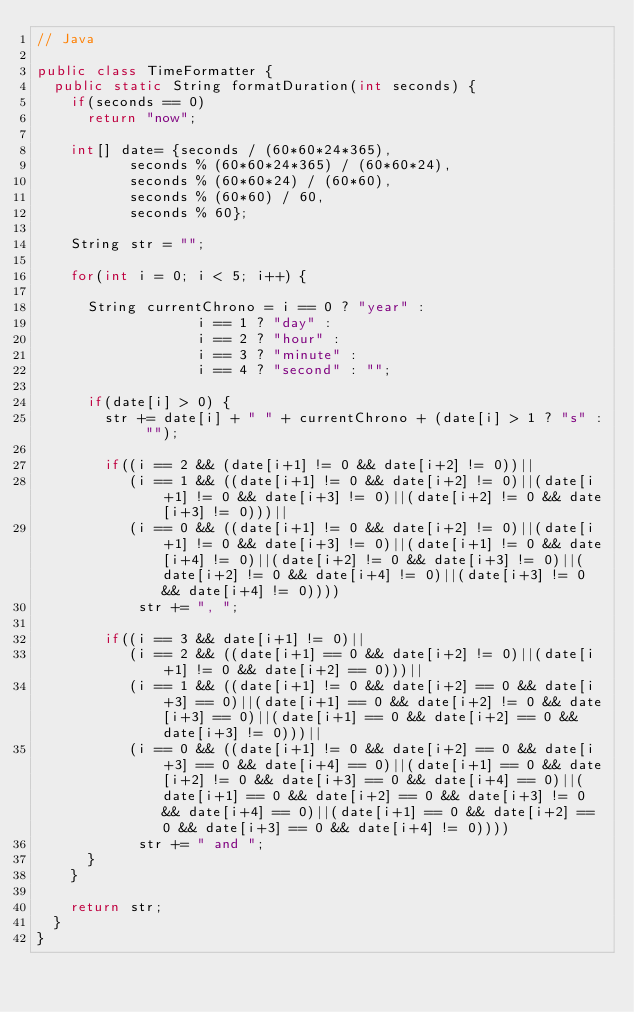Convert code to text. <code><loc_0><loc_0><loc_500><loc_500><_Java_>// Java

public class TimeFormatter {
  public static String formatDuration(int seconds) {
    if(seconds == 0)
      return "now";
    
    int[] date= {seconds / (60*60*24*365),
           seconds % (60*60*24*365) / (60*60*24),
           seconds % (60*60*24) / (60*60),
           seconds % (60*60) / 60,
           seconds % 60};
    
    String str = "";
    
    for(int i = 0; i < 5; i++) {
      
      String currentChrono = i == 0 ? "year" :
                   i == 1 ? "day" :
                   i == 2 ? "hour" : 
                   i == 3 ? "minute" : 
                   i == 4 ? "second" : "";
      
      if(date[i] > 0) {
        str += date[i] + " " + currentChrono + (date[i] > 1 ? "s" : "");
        
        if((i == 2 && (date[i+1] != 0 && date[i+2] != 0))||
           (i == 1 && ((date[i+1] != 0 && date[i+2] != 0)||(date[i+1] != 0 && date[i+3] != 0)||(date[i+2] != 0 && date[i+3] != 0)))||
           (i == 0 && ((date[i+1] != 0 && date[i+2] != 0)||(date[i+1] != 0 && date[i+3] != 0)||(date[i+1] != 0 && date[i+4] != 0)||(date[i+2] != 0 && date[i+3] != 0)||(date[i+2] != 0 && date[i+4] != 0)||(date[i+3] != 0 && date[i+4] != 0))))
            str += ", ";

        if((i == 3 && date[i+1] != 0)||
           (i == 2 && ((date[i+1] == 0 && date[i+2] != 0)||(date[i+1] != 0 && date[i+2] == 0)))||
           (i == 1 && ((date[i+1] != 0 && date[i+2] == 0 && date[i+3] == 0)||(date[i+1] == 0 && date[i+2] != 0 && date[i+3] == 0)||(date[i+1] == 0 && date[i+2] == 0 && date[i+3] != 0)))||
           (i == 0 && ((date[i+1] != 0 && date[i+2] == 0 && date[i+3] == 0 && date[i+4] == 0)||(date[i+1] == 0 && date[i+2] != 0 && date[i+3] == 0 && date[i+4] == 0)||(date[i+1] == 0 && date[i+2] == 0 && date[i+3] != 0 && date[i+4] == 0)||(date[i+1] == 0 && date[i+2] == 0 && date[i+3] == 0 && date[i+4] != 0))))
            str += " and ";
      }    
    }
    
    return str;
  }
}
</code> 